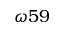Convert formula to latex. <formula><loc_0><loc_0><loc_500><loc_500>\omega 5 9</formula> 